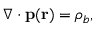<formula> <loc_0><loc_0><loc_500><loc_500>\nabla \cdot p ( r ) = \rho _ { b } ,</formula> 